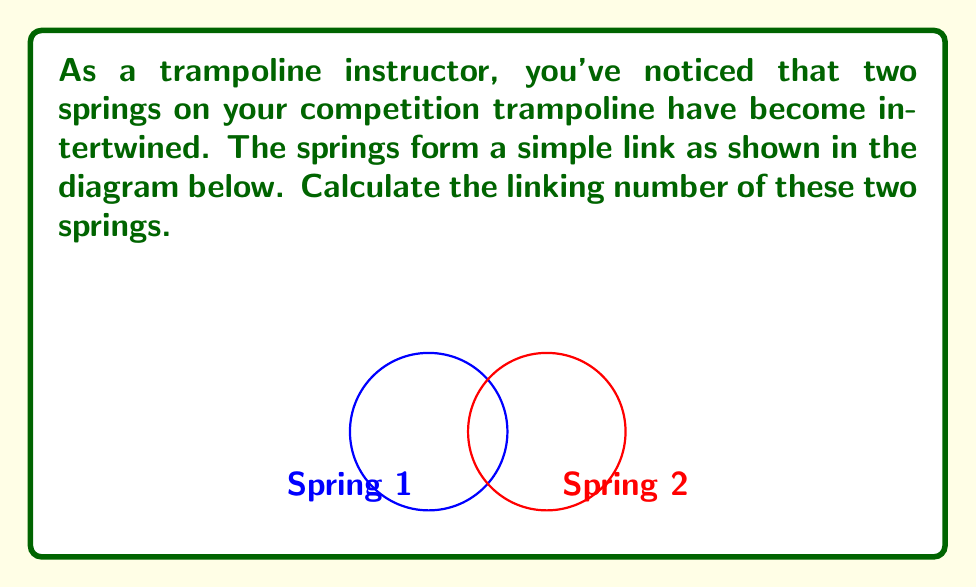What is the answer to this math problem? To calculate the linking number between two intertwined trampoline springs, we'll follow these steps:

1) The linking number is defined as half the sum of the signed crossings in a regular projection of the link.

2) In this case, we have a simple link of two circles (representing the springs) that form a Hopf link.

3) Let's project this 3D link onto a 2D plane. We'll choose the xy-plane for simplicity.

4) In this projection, we see two intersections between the springs.

5) We need to determine the sign of each crossing:
   - At one crossing, Spring 1 passes over Spring 2 from left to right: +1
   - At the other crossing, Spring 1 passes under Spring 2 from right to left: +1

6) The sum of the signed crossings is therefore: +1 + 1 = 2

7) The linking number is half of this sum:

   $$ \text{Linking Number} = \frac{1}{2} \sum \text{(signed crossings)} = \frac{1}{2} \cdot 2 = 1 $$

This linking number of 1 indicates that the springs are linked once, which is characteristic of a Hopf link.
Answer: 1 